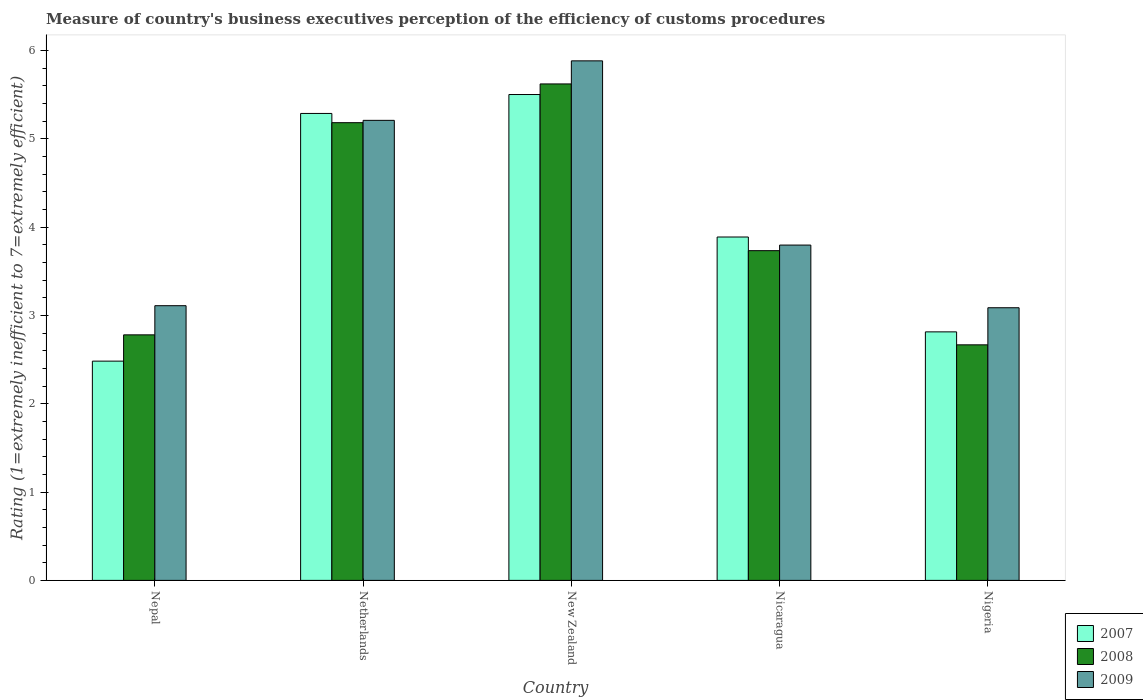How many different coloured bars are there?
Provide a succinct answer. 3. How many groups of bars are there?
Ensure brevity in your answer.  5. How many bars are there on the 2nd tick from the left?
Your response must be concise. 3. How many bars are there on the 3rd tick from the right?
Give a very brief answer. 3. What is the label of the 1st group of bars from the left?
Ensure brevity in your answer.  Nepal. In how many cases, is the number of bars for a given country not equal to the number of legend labels?
Provide a short and direct response. 0. What is the rating of the efficiency of customs procedure in 2007 in New Zealand?
Your answer should be very brief. 5.5. Across all countries, what is the maximum rating of the efficiency of customs procedure in 2009?
Your answer should be very brief. 5.88. Across all countries, what is the minimum rating of the efficiency of customs procedure in 2007?
Provide a succinct answer. 2.48. In which country was the rating of the efficiency of customs procedure in 2009 maximum?
Your answer should be compact. New Zealand. In which country was the rating of the efficiency of customs procedure in 2009 minimum?
Give a very brief answer. Nigeria. What is the total rating of the efficiency of customs procedure in 2007 in the graph?
Provide a short and direct response. 19.97. What is the difference between the rating of the efficiency of customs procedure in 2009 in Nepal and that in New Zealand?
Your response must be concise. -2.77. What is the difference between the rating of the efficiency of customs procedure in 2007 in Nepal and the rating of the efficiency of customs procedure in 2008 in Nicaragua?
Offer a terse response. -1.25. What is the average rating of the efficiency of customs procedure in 2009 per country?
Your answer should be very brief. 4.22. What is the difference between the rating of the efficiency of customs procedure of/in 2009 and rating of the efficiency of customs procedure of/in 2008 in Netherlands?
Your response must be concise. 0.03. What is the ratio of the rating of the efficiency of customs procedure in 2009 in New Zealand to that in Nigeria?
Offer a terse response. 1.91. What is the difference between the highest and the second highest rating of the efficiency of customs procedure in 2008?
Make the answer very short. 1.45. What is the difference between the highest and the lowest rating of the efficiency of customs procedure in 2009?
Ensure brevity in your answer.  2.79. Is it the case that in every country, the sum of the rating of the efficiency of customs procedure in 2008 and rating of the efficiency of customs procedure in 2009 is greater than the rating of the efficiency of customs procedure in 2007?
Keep it short and to the point. Yes. What is the difference between two consecutive major ticks on the Y-axis?
Make the answer very short. 1. Are the values on the major ticks of Y-axis written in scientific E-notation?
Give a very brief answer. No. Does the graph contain any zero values?
Make the answer very short. No. Does the graph contain grids?
Your answer should be very brief. No. How are the legend labels stacked?
Offer a very short reply. Vertical. What is the title of the graph?
Your answer should be compact. Measure of country's business executives perception of the efficiency of customs procedures. What is the label or title of the Y-axis?
Provide a succinct answer. Rating (1=extremely inefficient to 7=extremely efficient). What is the Rating (1=extremely inefficient to 7=extremely efficient) in 2007 in Nepal?
Give a very brief answer. 2.48. What is the Rating (1=extremely inefficient to 7=extremely efficient) in 2008 in Nepal?
Keep it short and to the point. 2.78. What is the Rating (1=extremely inefficient to 7=extremely efficient) in 2009 in Nepal?
Offer a terse response. 3.11. What is the Rating (1=extremely inefficient to 7=extremely efficient) of 2007 in Netherlands?
Provide a short and direct response. 5.29. What is the Rating (1=extremely inefficient to 7=extremely efficient) of 2008 in Netherlands?
Offer a terse response. 5.18. What is the Rating (1=extremely inefficient to 7=extremely efficient) in 2009 in Netherlands?
Give a very brief answer. 5.21. What is the Rating (1=extremely inefficient to 7=extremely efficient) of 2007 in New Zealand?
Your answer should be very brief. 5.5. What is the Rating (1=extremely inefficient to 7=extremely efficient) of 2008 in New Zealand?
Provide a short and direct response. 5.62. What is the Rating (1=extremely inefficient to 7=extremely efficient) of 2009 in New Zealand?
Your answer should be compact. 5.88. What is the Rating (1=extremely inefficient to 7=extremely efficient) of 2007 in Nicaragua?
Keep it short and to the point. 3.89. What is the Rating (1=extremely inefficient to 7=extremely efficient) in 2008 in Nicaragua?
Provide a short and direct response. 3.73. What is the Rating (1=extremely inefficient to 7=extremely efficient) in 2009 in Nicaragua?
Make the answer very short. 3.8. What is the Rating (1=extremely inefficient to 7=extremely efficient) of 2007 in Nigeria?
Ensure brevity in your answer.  2.81. What is the Rating (1=extremely inefficient to 7=extremely efficient) of 2008 in Nigeria?
Provide a succinct answer. 2.67. What is the Rating (1=extremely inefficient to 7=extremely efficient) in 2009 in Nigeria?
Make the answer very short. 3.09. Across all countries, what is the maximum Rating (1=extremely inefficient to 7=extremely efficient) of 2008?
Provide a short and direct response. 5.62. Across all countries, what is the maximum Rating (1=extremely inefficient to 7=extremely efficient) in 2009?
Your answer should be very brief. 5.88. Across all countries, what is the minimum Rating (1=extremely inefficient to 7=extremely efficient) of 2007?
Provide a succinct answer. 2.48. Across all countries, what is the minimum Rating (1=extremely inefficient to 7=extremely efficient) of 2008?
Provide a short and direct response. 2.67. Across all countries, what is the minimum Rating (1=extremely inefficient to 7=extremely efficient) in 2009?
Your response must be concise. 3.09. What is the total Rating (1=extremely inefficient to 7=extremely efficient) in 2007 in the graph?
Offer a terse response. 19.97. What is the total Rating (1=extremely inefficient to 7=extremely efficient) of 2008 in the graph?
Offer a very short reply. 19.98. What is the total Rating (1=extremely inefficient to 7=extremely efficient) in 2009 in the graph?
Make the answer very short. 21.08. What is the difference between the Rating (1=extremely inefficient to 7=extremely efficient) of 2007 in Nepal and that in Netherlands?
Give a very brief answer. -2.8. What is the difference between the Rating (1=extremely inefficient to 7=extremely efficient) in 2008 in Nepal and that in Netherlands?
Give a very brief answer. -2.4. What is the difference between the Rating (1=extremely inefficient to 7=extremely efficient) in 2009 in Nepal and that in Netherlands?
Provide a short and direct response. -2.1. What is the difference between the Rating (1=extremely inefficient to 7=extremely efficient) of 2007 in Nepal and that in New Zealand?
Provide a short and direct response. -3.02. What is the difference between the Rating (1=extremely inefficient to 7=extremely efficient) in 2008 in Nepal and that in New Zealand?
Your answer should be compact. -2.84. What is the difference between the Rating (1=extremely inefficient to 7=extremely efficient) in 2009 in Nepal and that in New Zealand?
Your answer should be compact. -2.77. What is the difference between the Rating (1=extremely inefficient to 7=extremely efficient) in 2007 in Nepal and that in Nicaragua?
Your response must be concise. -1.41. What is the difference between the Rating (1=extremely inefficient to 7=extremely efficient) in 2008 in Nepal and that in Nicaragua?
Keep it short and to the point. -0.95. What is the difference between the Rating (1=extremely inefficient to 7=extremely efficient) in 2009 in Nepal and that in Nicaragua?
Give a very brief answer. -0.69. What is the difference between the Rating (1=extremely inefficient to 7=extremely efficient) in 2007 in Nepal and that in Nigeria?
Offer a very short reply. -0.33. What is the difference between the Rating (1=extremely inefficient to 7=extremely efficient) of 2008 in Nepal and that in Nigeria?
Give a very brief answer. 0.11. What is the difference between the Rating (1=extremely inefficient to 7=extremely efficient) of 2009 in Nepal and that in Nigeria?
Your answer should be very brief. 0.02. What is the difference between the Rating (1=extremely inefficient to 7=extremely efficient) in 2007 in Netherlands and that in New Zealand?
Ensure brevity in your answer.  -0.21. What is the difference between the Rating (1=extremely inefficient to 7=extremely efficient) in 2008 in Netherlands and that in New Zealand?
Make the answer very short. -0.44. What is the difference between the Rating (1=extremely inefficient to 7=extremely efficient) of 2009 in Netherlands and that in New Zealand?
Your answer should be very brief. -0.67. What is the difference between the Rating (1=extremely inefficient to 7=extremely efficient) in 2007 in Netherlands and that in Nicaragua?
Give a very brief answer. 1.4. What is the difference between the Rating (1=extremely inefficient to 7=extremely efficient) of 2008 in Netherlands and that in Nicaragua?
Make the answer very short. 1.45. What is the difference between the Rating (1=extremely inefficient to 7=extremely efficient) in 2009 in Netherlands and that in Nicaragua?
Your answer should be very brief. 1.41. What is the difference between the Rating (1=extremely inefficient to 7=extremely efficient) of 2007 in Netherlands and that in Nigeria?
Give a very brief answer. 2.47. What is the difference between the Rating (1=extremely inefficient to 7=extremely efficient) in 2008 in Netherlands and that in Nigeria?
Your answer should be compact. 2.51. What is the difference between the Rating (1=extremely inefficient to 7=extremely efficient) in 2009 in Netherlands and that in Nigeria?
Offer a terse response. 2.12. What is the difference between the Rating (1=extremely inefficient to 7=extremely efficient) of 2007 in New Zealand and that in Nicaragua?
Offer a very short reply. 1.61. What is the difference between the Rating (1=extremely inefficient to 7=extremely efficient) of 2008 in New Zealand and that in Nicaragua?
Give a very brief answer. 1.89. What is the difference between the Rating (1=extremely inefficient to 7=extremely efficient) in 2009 in New Zealand and that in Nicaragua?
Your response must be concise. 2.09. What is the difference between the Rating (1=extremely inefficient to 7=extremely efficient) of 2007 in New Zealand and that in Nigeria?
Offer a very short reply. 2.69. What is the difference between the Rating (1=extremely inefficient to 7=extremely efficient) of 2008 in New Zealand and that in Nigeria?
Make the answer very short. 2.95. What is the difference between the Rating (1=extremely inefficient to 7=extremely efficient) of 2009 in New Zealand and that in Nigeria?
Provide a short and direct response. 2.79. What is the difference between the Rating (1=extremely inefficient to 7=extremely efficient) in 2007 in Nicaragua and that in Nigeria?
Your response must be concise. 1.07. What is the difference between the Rating (1=extremely inefficient to 7=extremely efficient) of 2008 in Nicaragua and that in Nigeria?
Your answer should be compact. 1.07. What is the difference between the Rating (1=extremely inefficient to 7=extremely efficient) of 2009 in Nicaragua and that in Nigeria?
Offer a very short reply. 0.71. What is the difference between the Rating (1=extremely inefficient to 7=extremely efficient) of 2007 in Nepal and the Rating (1=extremely inefficient to 7=extremely efficient) of 2008 in Netherlands?
Ensure brevity in your answer.  -2.7. What is the difference between the Rating (1=extremely inefficient to 7=extremely efficient) of 2007 in Nepal and the Rating (1=extremely inefficient to 7=extremely efficient) of 2009 in Netherlands?
Keep it short and to the point. -2.73. What is the difference between the Rating (1=extremely inefficient to 7=extremely efficient) in 2008 in Nepal and the Rating (1=extremely inefficient to 7=extremely efficient) in 2009 in Netherlands?
Make the answer very short. -2.43. What is the difference between the Rating (1=extremely inefficient to 7=extremely efficient) of 2007 in Nepal and the Rating (1=extremely inefficient to 7=extremely efficient) of 2008 in New Zealand?
Ensure brevity in your answer.  -3.14. What is the difference between the Rating (1=extremely inefficient to 7=extremely efficient) of 2007 in Nepal and the Rating (1=extremely inefficient to 7=extremely efficient) of 2009 in New Zealand?
Provide a succinct answer. -3.4. What is the difference between the Rating (1=extremely inefficient to 7=extremely efficient) in 2008 in Nepal and the Rating (1=extremely inefficient to 7=extremely efficient) in 2009 in New Zealand?
Give a very brief answer. -3.1. What is the difference between the Rating (1=extremely inefficient to 7=extremely efficient) in 2007 in Nepal and the Rating (1=extremely inefficient to 7=extremely efficient) in 2008 in Nicaragua?
Your answer should be very brief. -1.25. What is the difference between the Rating (1=extremely inefficient to 7=extremely efficient) of 2007 in Nepal and the Rating (1=extremely inefficient to 7=extremely efficient) of 2009 in Nicaragua?
Provide a succinct answer. -1.31. What is the difference between the Rating (1=extremely inefficient to 7=extremely efficient) in 2008 in Nepal and the Rating (1=extremely inefficient to 7=extremely efficient) in 2009 in Nicaragua?
Provide a succinct answer. -1.02. What is the difference between the Rating (1=extremely inefficient to 7=extremely efficient) of 2007 in Nepal and the Rating (1=extremely inefficient to 7=extremely efficient) of 2008 in Nigeria?
Your answer should be very brief. -0.18. What is the difference between the Rating (1=extremely inefficient to 7=extremely efficient) of 2007 in Nepal and the Rating (1=extremely inefficient to 7=extremely efficient) of 2009 in Nigeria?
Provide a succinct answer. -0.6. What is the difference between the Rating (1=extremely inefficient to 7=extremely efficient) of 2008 in Nepal and the Rating (1=extremely inefficient to 7=extremely efficient) of 2009 in Nigeria?
Ensure brevity in your answer.  -0.31. What is the difference between the Rating (1=extremely inefficient to 7=extremely efficient) of 2007 in Netherlands and the Rating (1=extremely inefficient to 7=extremely efficient) of 2008 in New Zealand?
Make the answer very short. -0.33. What is the difference between the Rating (1=extremely inefficient to 7=extremely efficient) in 2007 in Netherlands and the Rating (1=extremely inefficient to 7=extremely efficient) in 2009 in New Zealand?
Your answer should be compact. -0.6. What is the difference between the Rating (1=extremely inefficient to 7=extremely efficient) in 2008 in Netherlands and the Rating (1=extremely inefficient to 7=extremely efficient) in 2009 in New Zealand?
Offer a terse response. -0.7. What is the difference between the Rating (1=extremely inefficient to 7=extremely efficient) in 2007 in Netherlands and the Rating (1=extremely inefficient to 7=extremely efficient) in 2008 in Nicaragua?
Provide a succinct answer. 1.55. What is the difference between the Rating (1=extremely inefficient to 7=extremely efficient) of 2007 in Netherlands and the Rating (1=extremely inefficient to 7=extremely efficient) of 2009 in Nicaragua?
Your answer should be compact. 1.49. What is the difference between the Rating (1=extremely inefficient to 7=extremely efficient) of 2008 in Netherlands and the Rating (1=extremely inefficient to 7=extremely efficient) of 2009 in Nicaragua?
Keep it short and to the point. 1.39. What is the difference between the Rating (1=extremely inefficient to 7=extremely efficient) in 2007 in Netherlands and the Rating (1=extremely inefficient to 7=extremely efficient) in 2008 in Nigeria?
Ensure brevity in your answer.  2.62. What is the difference between the Rating (1=extremely inefficient to 7=extremely efficient) of 2007 in Netherlands and the Rating (1=extremely inefficient to 7=extremely efficient) of 2009 in Nigeria?
Your response must be concise. 2.2. What is the difference between the Rating (1=extremely inefficient to 7=extremely efficient) of 2008 in Netherlands and the Rating (1=extremely inefficient to 7=extremely efficient) of 2009 in Nigeria?
Offer a terse response. 2.1. What is the difference between the Rating (1=extremely inefficient to 7=extremely efficient) in 2007 in New Zealand and the Rating (1=extremely inefficient to 7=extremely efficient) in 2008 in Nicaragua?
Ensure brevity in your answer.  1.77. What is the difference between the Rating (1=extremely inefficient to 7=extremely efficient) of 2007 in New Zealand and the Rating (1=extremely inefficient to 7=extremely efficient) of 2009 in Nicaragua?
Your answer should be very brief. 1.7. What is the difference between the Rating (1=extremely inefficient to 7=extremely efficient) of 2008 in New Zealand and the Rating (1=extremely inefficient to 7=extremely efficient) of 2009 in Nicaragua?
Offer a very short reply. 1.82. What is the difference between the Rating (1=extremely inefficient to 7=extremely efficient) in 2007 in New Zealand and the Rating (1=extremely inefficient to 7=extremely efficient) in 2008 in Nigeria?
Make the answer very short. 2.83. What is the difference between the Rating (1=extremely inefficient to 7=extremely efficient) of 2007 in New Zealand and the Rating (1=extremely inefficient to 7=extremely efficient) of 2009 in Nigeria?
Ensure brevity in your answer.  2.41. What is the difference between the Rating (1=extremely inefficient to 7=extremely efficient) of 2008 in New Zealand and the Rating (1=extremely inefficient to 7=extremely efficient) of 2009 in Nigeria?
Provide a short and direct response. 2.53. What is the difference between the Rating (1=extremely inefficient to 7=extremely efficient) in 2007 in Nicaragua and the Rating (1=extremely inefficient to 7=extremely efficient) in 2008 in Nigeria?
Ensure brevity in your answer.  1.22. What is the difference between the Rating (1=extremely inefficient to 7=extremely efficient) of 2007 in Nicaragua and the Rating (1=extremely inefficient to 7=extremely efficient) of 2009 in Nigeria?
Your answer should be very brief. 0.8. What is the difference between the Rating (1=extremely inefficient to 7=extremely efficient) of 2008 in Nicaragua and the Rating (1=extremely inefficient to 7=extremely efficient) of 2009 in Nigeria?
Offer a terse response. 0.65. What is the average Rating (1=extremely inefficient to 7=extremely efficient) of 2007 per country?
Provide a succinct answer. 3.99. What is the average Rating (1=extremely inefficient to 7=extremely efficient) in 2008 per country?
Keep it short and to the point. 4. What is the average Rating (1=extremely inefficient to 7=extremely efficient) in 2009 per country?
Give a very brief answer. 4.22. What is the difference between the Rating (1=extremely inefficient to 7=extremely efficient) in 2007 and Rating (1=extremely inefficient to 7=extremely efficient) in 2008 in Nepal?
Provide a succinct answer. -0.3. What is the difference between the Rating (1=extremely inefficient to 7=extremely efficient) of 2007 and Rating (1=extremely inefficient to 7=extremely efficient) of 2009 in Nepal?
Offer a very short reply. -0.63. What is the difference between the Rating (1=extremely inefficient to 7=extremely efficient) in 2008 and Rating (1=extremely inefficient to 7=extremely efficient) in 2009 in Nepal?
Provide a short and direct response. -0.33. What is the difference between the Rating (1=extremely inefficient to 7=extremely efficient) in 2007 and Rating (1=extremely inefficient to 7=extremely efficient) in 2008 in Netherlands?
Keep it short and to the point. 0.1. What is the difference between the Rating (1=extremely inefficient to 7=extremely efficient) in 2007 and Rating (1=extremely inefficient to 7=extremely efficient) in 2009 in Netherlands?
Offer a very short reply. 0.08. What is the difference between the Rating (1=extremely inefficient to 7=extremely efficient) in 2008 and Rating (1=extremely inefficient to 7=extremely efficient) in 2009 in Netherlands?
Give a very brief answer. -0.03. What is the difference between the Rating (1=extremely inefficient to 7=extremely efficient) of 2007 and Rating (1=extremely inefficient to 7=extremely efficient) of 2008 in New Zealand?
Your answer should be compact. -0.12. What is the difference between the Rating (1=extremely inefficient to 7=extremely efficient) of 2007 and Rating (1=extremely inefficient to 7=extremely efficient) of 2009 in New Zealand?
Offer a very short reply. -0.38. What is the difference between the Rating (1=extremely inefficient to 7=extremely efficient) in 2008 and Rating (1=extremely inefficient to 7=extremely efficient) in 2009 in New Zealand?
Give a very brief answer. -0.26. What is the difference between the Rating (1=extremely inefficient to 7=extremely efficient) of 2007 and Rating (1=extremely inefficient to 7=extremely efficient) of 2008 in Nicaragua?
Your answer should be compact. 0.15. What is the difference between the Rating (1=extremely inefficient to 7=extremely efficient) in 2007 and Rating (1=extremely inefficient to 7=extremely efficient) in 2009 in Nicaragua?
Offer a terse response. 0.09. What is the difference between the Rating (1=extremely inefficient to 7=extremely efficient) in 2008 and Rating (1=extremely inefficient to 7=extremely efficient) in 2009 in Nicaragua?
Provide a succinct answer. -0.06. What is the difference between the Rating (1=extremely inefficient to 7=extremely efficient) in 2007 and Rating (1=extremely inefficient to 7=extremely efficient) in 2008 in Nigeria?
Ensure brevity in your answer.  0.15. What is the difference between the Rating (1=extremely inefficient to 7=extremely efficient) of 2007 and Rating (1=extremely inefficient to 7=extremely efficient) of 2009 in Nigeria?
Offer a very short reply. -0.27. What is the difference between the Rating (1=extremely inefficient to 7=extremely efficient) of 2008 and Rating (1=extremely inefficient to 7=extremely efficient) of 2009 in Nigeria?
Provide a succinct answer. -0.42. What is the ratio of the Rating (1=extremely inefficient to 7=extremely efficient) in 2007 in Nepal to that in Netherlands?
Keep it short and to the point. 0.47. What is the ratio of the Rating (1=extremely inefficient to 7=extremely efficient) in 2008 in Nepal to that in Netherlands?
Keep it short and to the point. 0.54. What is the ratio of the Rating (1=extremely inefficient to 7=extremely efficient) in 2009 in Nepal to that in Netherlands?
Ensure brevity in your answer.  0.6. What is the ratio of the Rating (1=extremely inefficient to 7=extremely efficient) in 2007 in Nepal to that in New Zealand?
Make the answer very short. 0.45. What is the ratio of the Rating (1=extremely inefficient to 7=extremely efficient) in 2008 in Nepal to that in New Zealand?
Make the answer very short. 0.49. What is the ratio of the Rating (1=extremely inefficient to 7=extremely efficient) in 2009 in Nepal to that in New Zealand?
Keep it short and to the point. 0.53. What is the ratio of the Rating (1=extremely inefficient to 7=extremely efficient) of 2007 in Nepal to that in Nicaragua?
Your answer should be compact. 0.64. What is the ratio of the Rating (1=extremely inefficient to 7=extremely efficient) of 2008 in Nepal to that in Nicaragua?
Offer a terse response. 0.74. What is the ratio of the Rating (1=extremely inefficient to 7=extremely efficient) in 2009 in Nepal to that in Nicaragua?
Provide a short and direct response. 0.82. What is the ratio of the Rating (1=extremely inefficient to 7=extremely efficient) in 2007 in Nepal to that in Nigeria?
Offer a very short reply. 0.88. What is the ratio of the Rating (1=extremely inefficient to 7=extremely efficient) of 2008 in Nepal to that in Nigeria?
Give a very brief answer. 1.04. What is the ratio of the Rating (1=extremely inefficient to 7=extremely efficient) in 2009 in Nepal to that in Nigeria?
Give a very brief answer. 1.01. What is the ratio of the Rating (1=extremely inefficient to 7=extremely efficient) in 2007 in Netherlands to that in New Zealand?
Your response must be concise. 0.96. What is the ratio of the Rating (1=extremely inefficient to 7=extremely efficient) of 2008 in Netherlands to that in New Zealand?
Provide a succinct answer. 0.92. What is the ratio of the Rating (1=extremely inefficient to 7=extremely efficient) in 2009 in Netherlands to that in New Zealand?
Ensure brevity in your answer.  0.89. What is the ratio of the Rating (1=extremely inefficient to 7=extremely efficient) of 2007 in Netherlands to that in Nicaragua?
Your answer should be very brief. 1.36. What is the ratio of the Rating (1=extremely inefficient to 7=extremely efficient) of 2008 in Netherlands to that in Nicaragua?
Give a very brief answer. 1.39. What is the ratio of the Rating (1=extremely inefficient to 7=extremely efficient) of 2009 in Netherlands to that in Nicaragua?
Keep it short and to the point. 1.37. What is the ratio of the Rating (1=extremely inefficient to 7=extremely efficient) in 2007 in Netherlands to that in Nigeria?
Provide a short and direct response. 1.88. What is the ratio of the Rating (1=extremely inefficient to 7=extremely efficient) of 2008 in Netherlands to that in Nigeria?
Keep it short and to the point. 1.94. What is the ratio of the Rating (1=extremely inefficient to 7=extremely efficient) in 2009 in Netherlands to that in Nigeria?
Keep it short and to the point. 1.69. What is the ratio of the Rating (1=extremely inefficient to 7=extremely efficient) in 2007 in New Zealand to that in Nicaragua?
Give a very brief answer. 1.41. What is the ratio of the Rating (1=extremely inefficient to 7=extremely efficient) of 2008 in New Zealand to that in Nicaragua?
Your response must be concise. 1.51. What is the ratio of the Rating (1=extremely inefficient to 7=extremely efficient) of 2009 in New Zealand to that in Nicaragua?
Give a very brief answer. 1.55. What is the ratio of the Rating (1=extremely inefficient to 7=extremely efficient) in 2007 in New Zealand to that in Nigeria?
Offer a terse response. 1.96. What is the ratio of the Rating (1=extremely inefficient to 7=extremely efficient) of 2008 in New Zealand to that in Nigeria?
Provide a short and direct response. 2.11. What is the ratio of the Rating (1=extremely inefficient to 7=extremely efficient) in 2009 in New Zealand to that in Nigeria?
Your response must be concise. 1.91. What is the ratio of the Rating (1=extremely inefficient to 7=extremely efficient) in 2007 in Nicaragua to that in Nigeria?
Keep it short and to the point. 1.38. What is the ratio of the Rating (1=extremely inefficient to 7=extremely efficient) of 2008 in Nicaragua to that in Nigeria?
Give a very brief answer. 1.4. What is the ratio of the Rating (1=extremely inefficient to 7=extremely efficient) in 2009 in Nicaragua to that in Nigeria?
Keep it short and to the point. 1.23. What is the difference between the highest and the second highest Rating (1=extremely inefficient to 7=extremely efficient) of 2007?
Your answer should be compact. 0.21. What is the difference between the highest and the second highest Rating (1=extremely inefficient to 7=extremely efficient) of 2008?
Your answer should be very brief. 0.44. What is the difference between the highest and the second highest Rating (1=extremely inefficient to 7=extremely efficient) of 2009?
Make the answer very short. 0.67. What is the difference between the highest and the lowest Rating (1=extremely inefficient to 7=extremely efficient) in 2007?
Your answer should be very brief. 3.02. What is the difference between the highest and the lowest Rating (1=extremely inefficient to 7=extremely efficient) of 2008?
Offer a very short reply. 2.95. What is the difference between the highest and the lowest Rating (1=extremely inefficient to 7=extremely efficient) in 2009?
Your answer should be very brief. 2.79. 